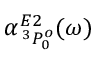Convert formula to latex. <formula><loc_0><loc_0><loc_500><loc_500>\alpha _ { \, ^ { 3 } P _ { 0 } ^ { o } } ^ { E 2 } ( \omega )</formula> 